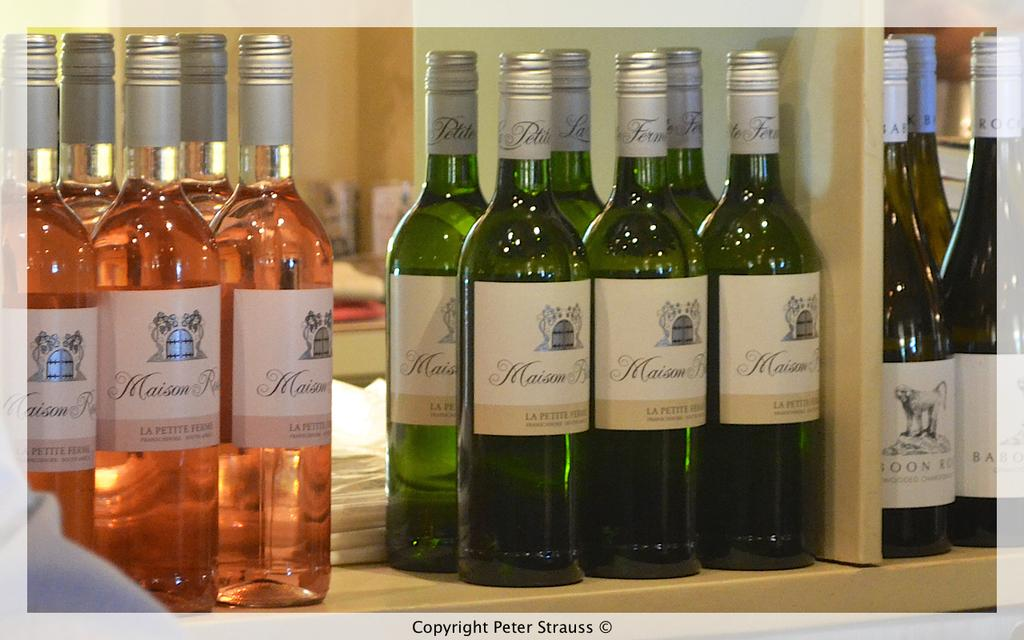Provide a one-sentence caption for the provided image. Wine displayed on a store shelf, several different varities including LA Petite Ferms. 